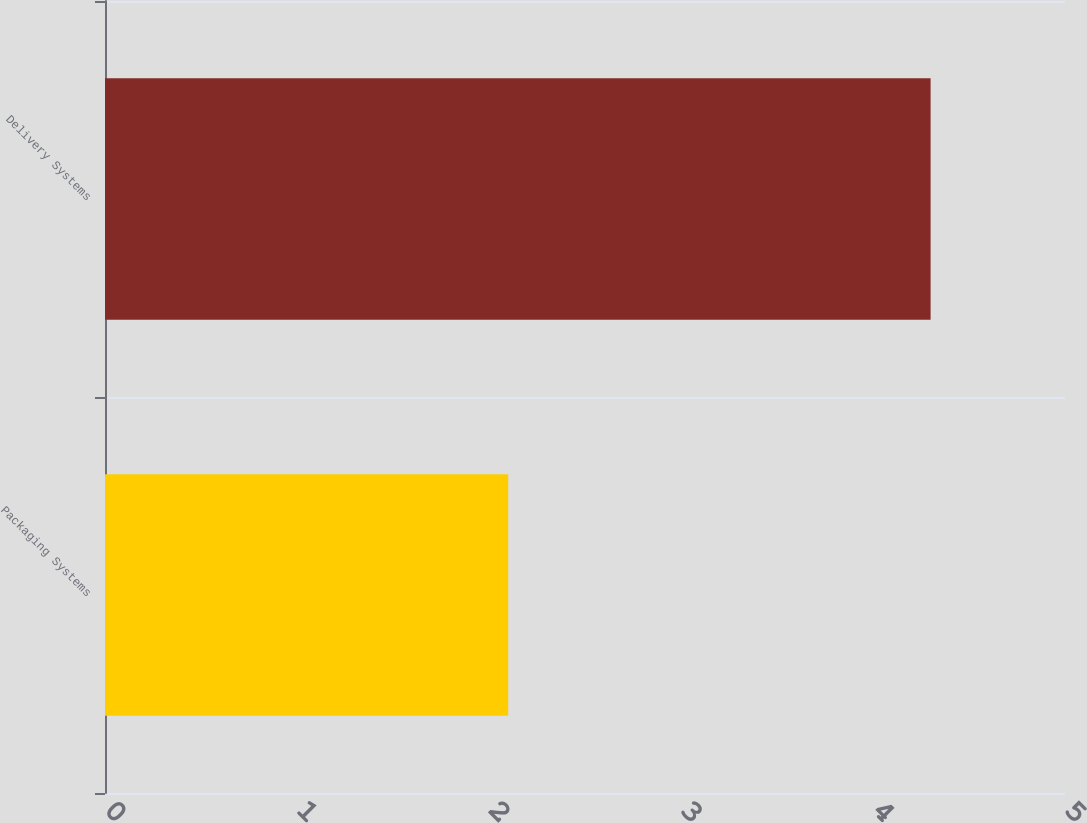Convert chart to OTSL. <chart><loc_0><loc_0><loc_500><loc_500><bar_chart><fcel>Packaging Systems<fcel>Delivery Systems<nl><fcel>2.1<fcel>4.3<nl></chart> 